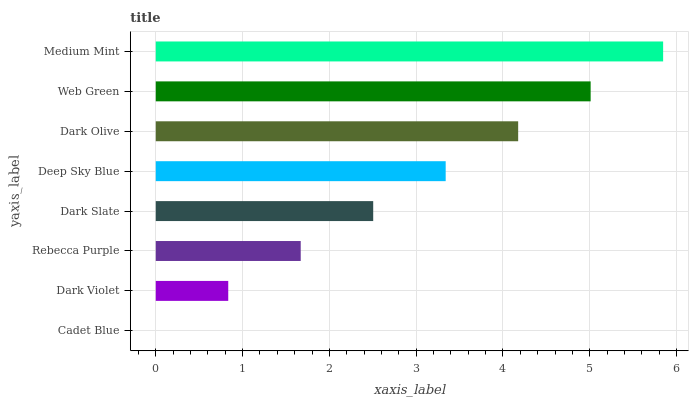Is Cadet Blue the minimum?
Answer yes or no. Yes. Is Medium Mint the maximum?
Answer yes or no. Yes. Is Dark Violet the minimum?
Answer yes or no. No. Is Dark Violet the maximum?
Answer yes or no. No. Is Dark Violet greater than Cadet Blue?
Answer yes or no. Yes. Is Cadet Blue less than Dark Violet?
Answer yes or no. Yes. Is Cadet Blue greater than Dark Violet?
Answer yes or no. No. Is Dark Violet less than Cadet Blue?
Answer yes or no. No. Is Deep Sky Blue the high median?
Answer yes or no. Yes. Is Dark Slate the low median?
Answer yes or no. Yes. Is Cadet Blue the high median?
Answer yes or no. No. Is Medium Mint the low median?
Answer yes or no. No. 